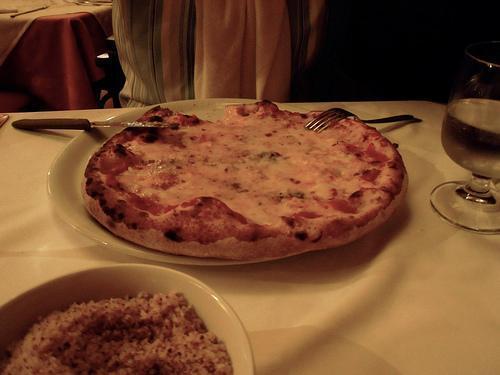How many eating utensils are visible?
Give a very brief answer. 2. 